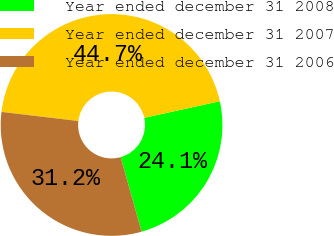<chart> <loc_0><loc_0><loc_500><loc_500><pie_chart><fcel>Year ended december 31 2008<fcel>Year ended december 31 2007<fcel>Year ended december 31 2006<nl><fcel>24.07%<fcel>44.68%<fcel>31.25%<nl></chart> 